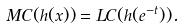Convert formula to latex. <formula><loc_0><loc_0><loc_500><loc_500>M C ( h ( x ) ) = L C ( h ( e ^ { - t } ) ) .</formula> 